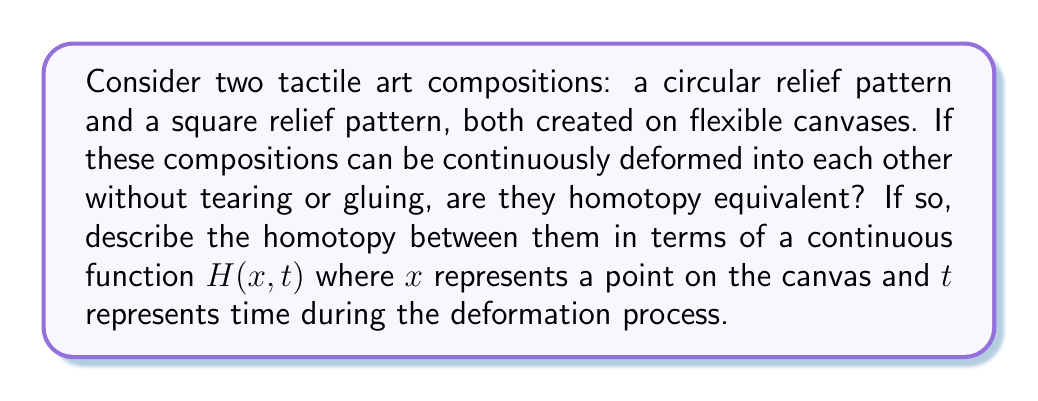Could you help me with this problem? To determine if the circular and square relief patterns are homotopy equivalent, we need to consider if there exists a continuous deformation from one to the other.

1. Topological properties:
   Both the circular and square patterns are created on flexible canvases, which means they can be deformed without changing their fundamental topological properties.

2. Homotopy equivalence:
   Two topological spaces X and Y are homotopy equivalent if there exist continuous maps $f: X \to Y$ and $g: Y \to X$ such that the compositions $g \circ f$ and $f \circ g$ are homotopic to the identity maps on X and Y, respectively.

3. Deformation process:
   We can imagine a continuous deformation process where the circular canvas is gradually stretched and reshaped into a square form, and vice versa. This process doesn't involve tearing or gluing, preserving the topological structure.

4. Homotopy function:
   Let's define the homotopy function $H: X \times [0,1] \to Y$, where X is the initial shape (circle) and Y is the final shape (square).

   $H(x, t) = (1-t)f_circle(x) + tf_square(x)$

   Where:
   - $f_circle(x)$ represents the position of a point x on the circular canvas
   - $f_square(x)$ represents the position of the corresponding point on the square canvas
   - $t$ varies from 0 to 1, representing the progression of the deformation

5. Continuity:
   The function H is continuous in both x and t, ensuring a smooth transition between the two shapes.

6. Inverse homotopy:
   We can define a similar homotopy function for the inverse process (square to circle), demonstrating that the relationship is symmetric.

Therefore, the circular and square relief patterns are indeed homotopy equivalent, as we can continuously deform one into the other while preserving their topological properties.
Answer: Yes, the circular and square relief patterns are homotopy equivalent. The homotopy between them can be described by the continuous function:

$H(x, t) = (1-t)f_circle(x) + tf_square(x)$

Where $x$ represents a point on the canvas, $t \in [0,1]$ represents time during the deformation process, and $f_circle(x)$ and $f_square(x)$ represent the positions of corresponding points on the circular and square canvases, respectively. 